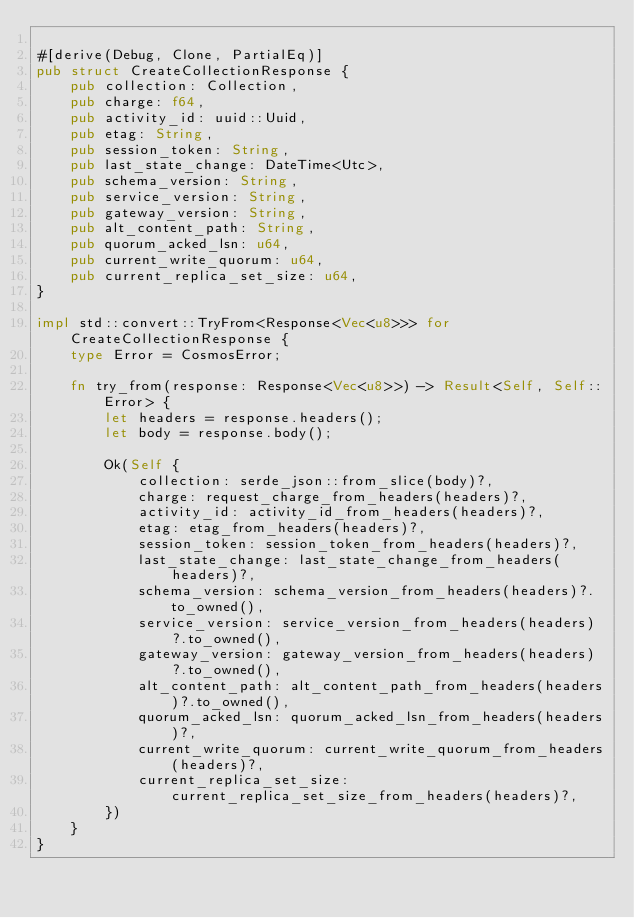Convert code to text. <code><loc_0><loc_0><loc_500><loc_500><_Rust_>
#[derive(Debug, Clone, PartialEq)]
pub struct CreateCollectionResponse {
    pub collection: Collection,
    pub charge: f64,
    pub activity_id: uuid::Uuid,
    pub etag: String,
    pub session_token: String,
    pub last_state_change: DateTime<Utc>,
    pub schema_version: String,
    pub service_version: String,
    pub gateway_version: String,
    pub alt_content_path: String,
    pub quorum_acked_lsn: u64,
    pub current_write_quorum: u64,
    pub current_replica_set_size: u64,
}

impl std::convert::TryFrom<Response<Vec<u8>>> for CreateCollectionResponse {
    type Error = CosmosError;

    fn try_from(response: Response<Vec<u8>>) -> Result<Self, Self::Error> {
        let headers = response.headers();
        let body = response.body();

        Ok(Self {
            collection: serde_json::from_slice(body)?,
            charge: request_charge_from_headers(headers)?,
            activity_id: activity_id_from_headers(headers)?,
            etag: etag_from_headers(headers)?,
            session_token: session_token_from_headers(headers)?,
            last_state_change: last_state_change_from_headers(headers)?,
            schema_version: schema_version_from_headers(headers)?.to_owned(),
            service_version: service_version_from_headers(headers)?.to_owned(),
            gateway_version: gateway_version_from_headers(headers)?.to_owned(),
            alt_content_path: alt_content_path_from_headers(headers)?.to_owned(),
            quorum_acked_lsn: quorum_acked_lsn_from_headers(headers)?,
            current_write_quorum: current_write_quorum_from_headers(headers)?,
            current_replica_set_size: current_replica_set_size_from_headers(headers)?,
        })
    }
}
</code> 